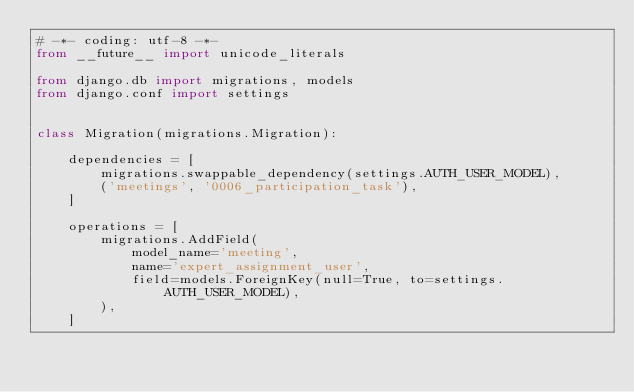<code> <loc_0><loc_0><loc_500><loc_500><_Python_># -*- coding: utf-8 -*-
from __future__ import unicode_literals

from django.db import migrations, models
from django.conf import settings


class Migration(migrations.Migration):

    dependencies = [
        migrations.swappable_dependency(settings.AUTH_USER_MODEL),
        ('meetings', '0006_participation_task'),
    ]

    operations = [
        migrations.AddField(
            model_name='meeting',
            name='expert_assignment_user',
            field=models.ForeignKey(null=True, to=settings.AUTH_USER_MODEL),
        ),
    ]
</code> 